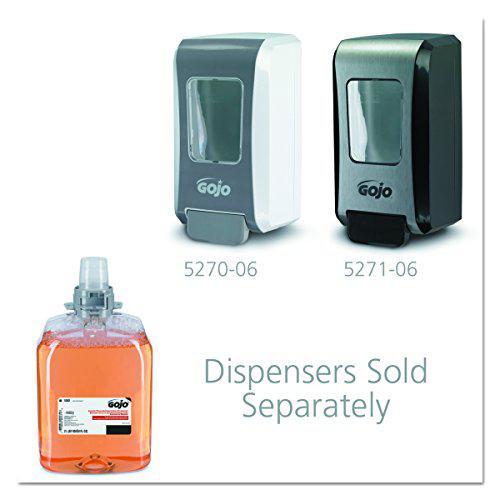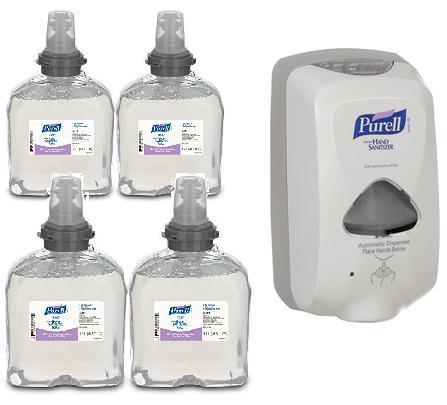The first image is the image on the left, the second image is the image on the right. Given the left and right images, does the statement "The left and right image contains a total of three wall soap dispensers." hold true? Answer yes or no. Yes. The first image is the image on the left, the second image is the image on the right. Considering the images on both sides, is "An image shows a bottle of hand soap on the lower left, and at least two versions of the same style wall-mounted dispenser above it." valid? Answer yes or no. Yes. 